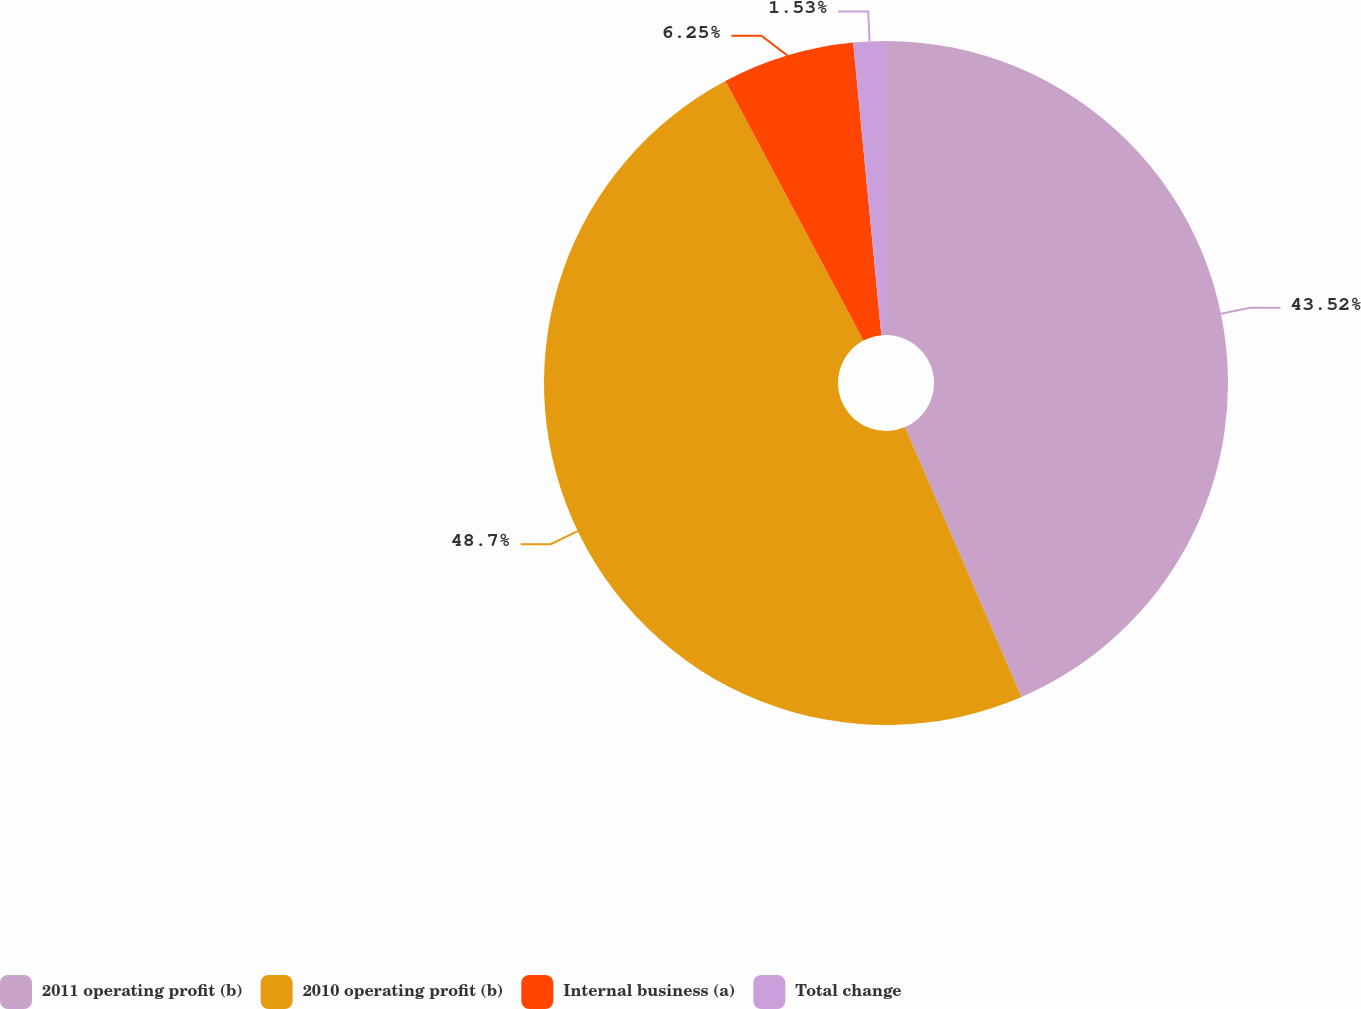Convert chart. <chart><loc_0><loc_0><loc_500><loc_500><pie_chart><fcel>2011 operating profit (b)<fcel>2010 operating profit (b)<fcel>Internal business (a)<fcel>Total change<nl><fcel>43.52%<fcel>48.71%<fcel>6.25%<fcel>1.53%<nl></chart> 